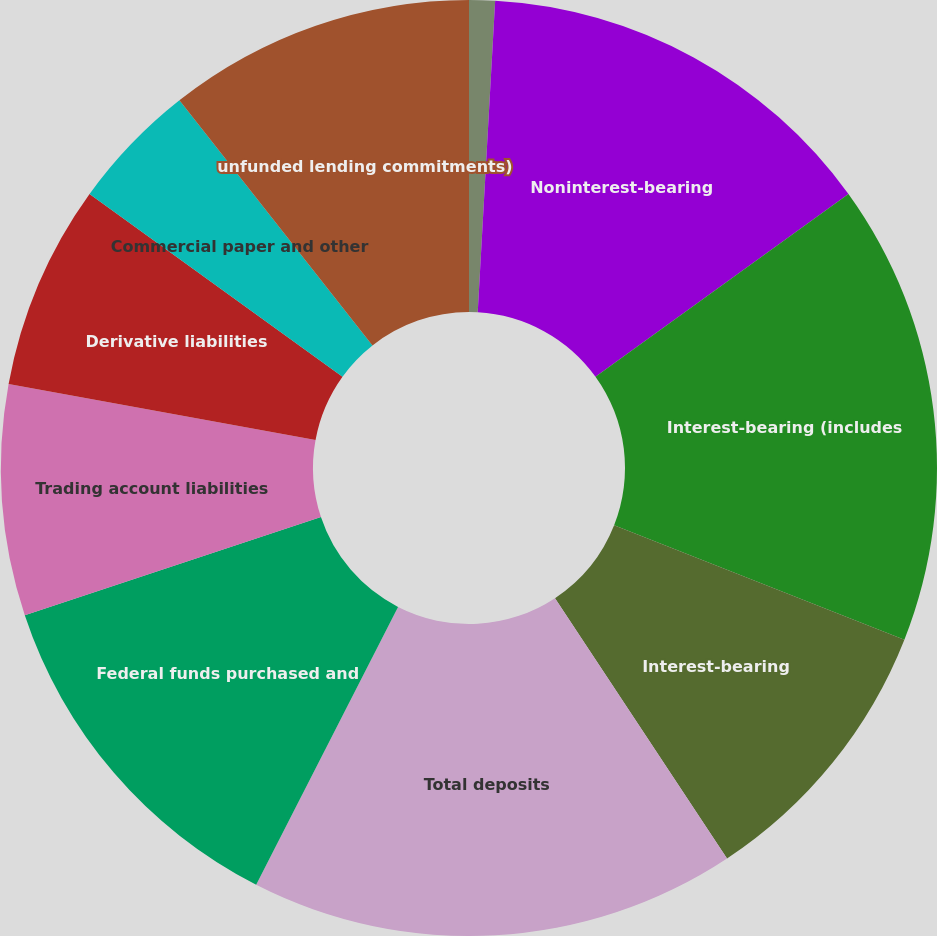Convert chart to OTSL. <chart><loc_0><loc_0><loc_500><loc_500><pie_chart><fcel>(Dollars in millions)<fcel>Noninterest-bearing<fcel>Interest-bearing (includes<fcel>Interest-bearing<fcel>Total deposits<fcel>Federal funds purchased and<fcel>Trading account liabilities<fcel>Derivative liabilities<fcel>Commercial paper and other<fcel>unfunded lending commitments)<nl><fcel>0.89%<fcel>14.16%<fcel>15.93%<fcel>9.73%<fcel>16.81%<fcel>12.39%<fcel>7.97%<fcel>7.08%<fcel>4.43%<fcel>10.62%<nl></chart> 